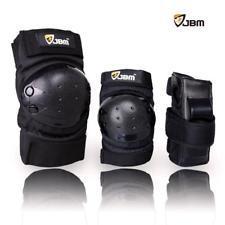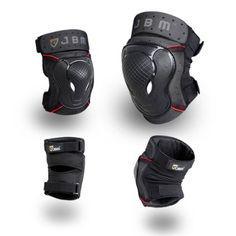The first image is the image on the left, the second image is the image on the right. Given the left and right images, does the statement "There are at least eight pieces of black gear featured." hold true? Answer yes or no. No. The first image is the image on the left, the second image is the image on the right. Examine the images to the left and right. Is the description "At least one image in the set contains exactly four kneepads, with no lettering on them or brand names." accurate? Answer yes or no. No. 